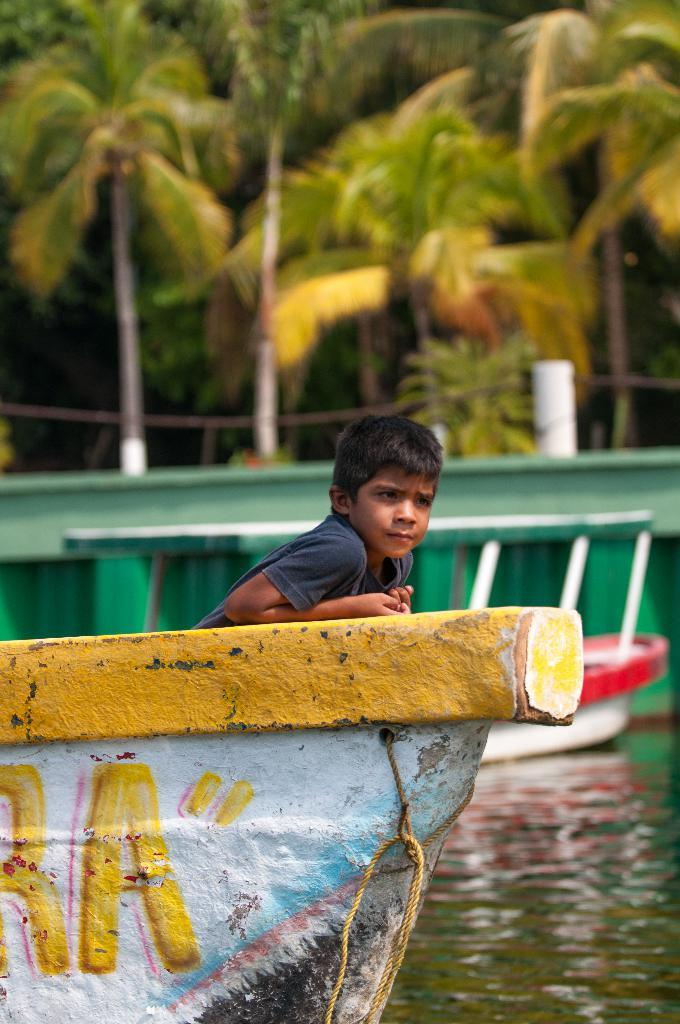How many boats are visible in the image? There are two boats in the image. Where are the boats located? The boats are on the water. Is there anyone on the boats? Yes, there is a boy on one of the boats. What can be seen in the background of the image? There is a wall and trees in the background of the image. What type of grip does the boy have on the gun in the image? There is no gun present in the image; it only features two boats, a boy on one of them, and a background with a wall and trees. 